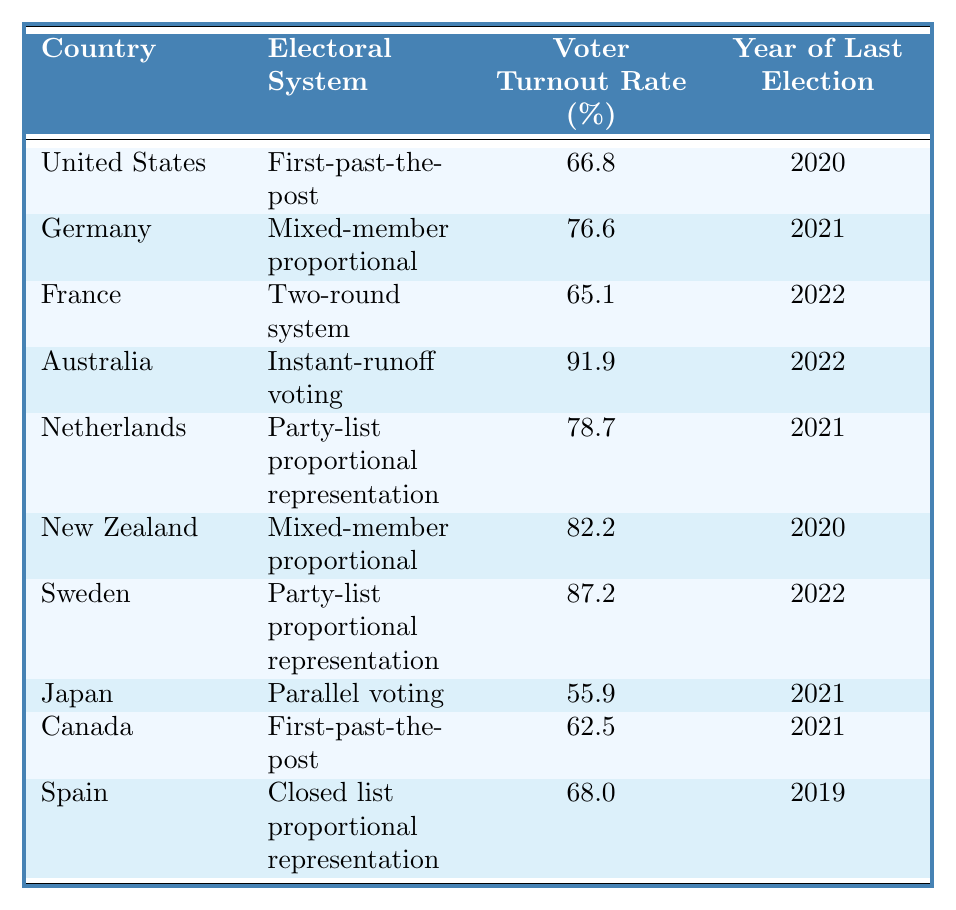What is the voter turnout rate in Australia? According to the table, Australia has a voter turnout rate of 91.9%.
Answer: 91.9% Which country has the lowest voter turnout rate? The table indicates that Japan has the lowest voter turnout rate at 55.9%.
Answer: Japan What electoral system does Germany use? From the table, Germany uses a mixed-member proportional electoral system.
Answer: Mixed-member proportional What is the voter turnout rate for countries using the first-past-the-post system? The table shows that the United States has 66.8% and Canada has 62.5%, so the average is (66.8 + 62.5) / 2 = 64.65%.
Answer: 64.65% Is the voter turnout rate in France higher than in the Netherlands? The table shows France at 65.1% and the Netherlands at 78.7%, so the statement is false.
Answer: No What is the average voter turnout rate of countries with party-list proportional representation? The data shows Sweden at 87.2% and the Netherlands at 78.7%, resulting in (87.2 + 78.7) / 2 = 82.95%.
Answer: 82.95% How many countries have a voter turnout rate above 80%? The table lists Australia (91.9%), New Zealand (82.2%), and Sweden (87.2%), totaling three countries.
Answer: 3 Which electoral system has the highest voter turnout rate and what is that rate? The table highlights that instant-runoff voting in Australia has the highest rate at 91.9%.
Answer: Instant-runoff voting, 91.9% Compare the voter turnout rates of New Zealand and Spain—who has a higher turnout and by how much? New Zealand's rate is 82.2% while Spain's is 68.0%. The difference is 82.2% - 68.0% = 14.2%.
Answer: New Zealand, 14.2% What is the total voter turnout rate of all the countries listed? Adding the rates: 66.8 + 76.6 + 65.1 + 91.9 + 78.7 + 82.2 + 87.2 + 55.9 + 62.5 + 68.0 =  792.0%. Therefore, the total turnout rate is 792.0%.
Answer: 792.0% 